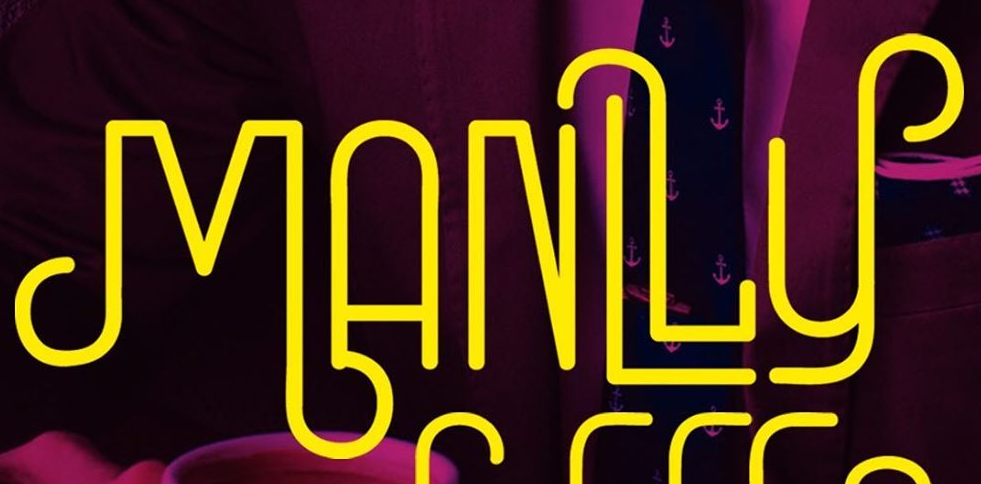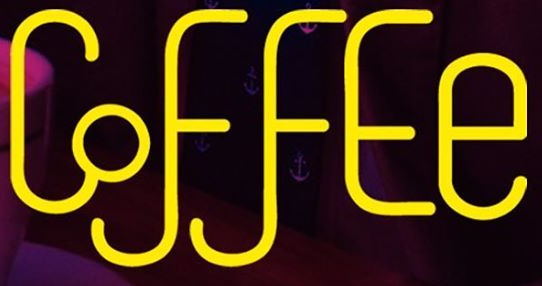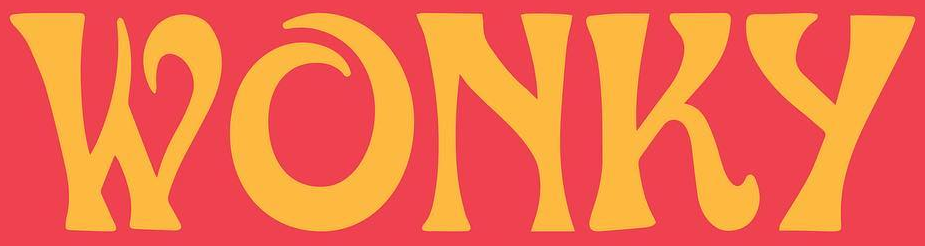Read the text from these images in sequence, separated by a semicolon. MANLLy; CoffEe; WONKy 